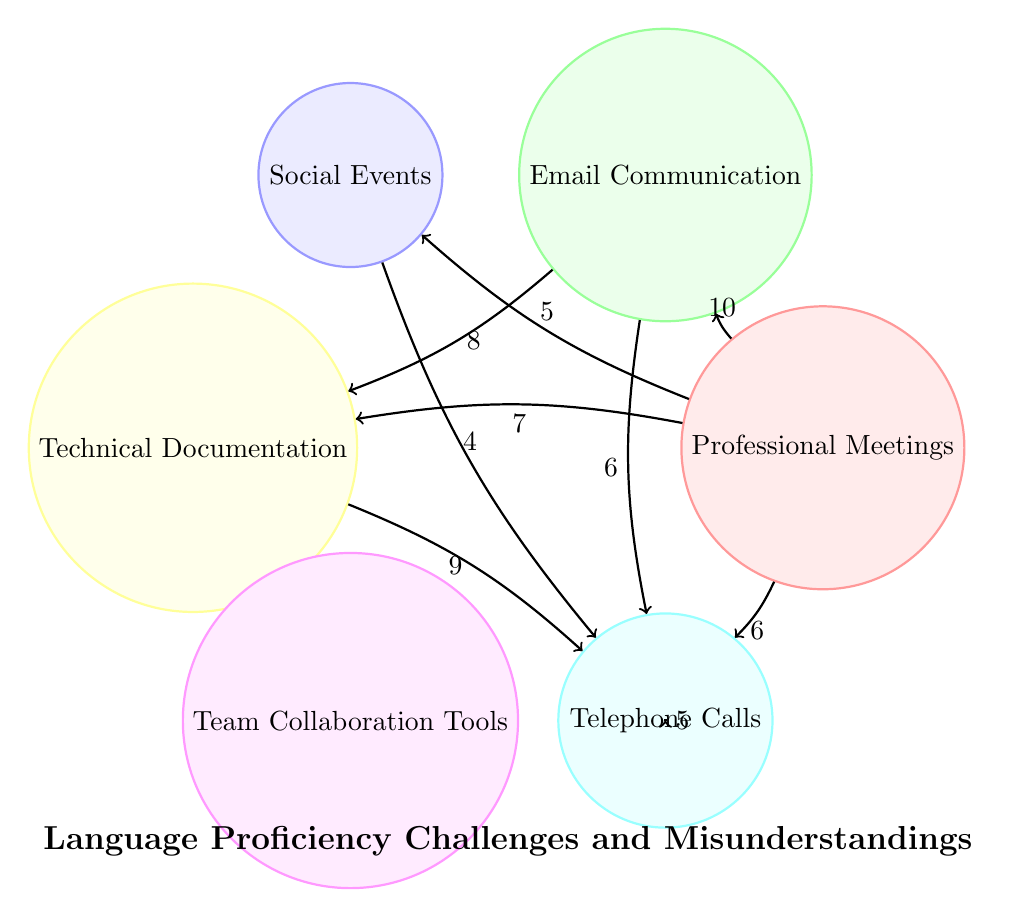What is the value linking Professional Meetings to Email Communication? The diagram shows that the value of the link from Professional Meetings to Email Communication is indicated as 10.
Answer: 10 How many nodes are present in the diagram? The diagram has six nodes: Professional Meetings, Email Communication, Social Events, Technical Documentation, Team Collaboration Tools, and Telephone Calls.
Answer: 6 Which context has the highest frequency of misunderstandings? Looking at the link values, the highest value is 10, which connects Professional Meetings to Email Communication, indicating that it has the highest frequency of misunderstandings.
Answer: Professional Meetings to Email Communication What is the value of misunderstandings between Technical Documentation and Team Collaboration Tools? The link between Technical Documentation and Team Collaboration Tools is presented with a value of 9, indicating the frequency of misunderstandings in that context.
Answer: 9 Which two contexts have the least value based on the linked data? The least values shown in the diagram are 4 between Social Events and Telephone Calls, and 5 between Social Events and Team Collaboration Tools, making these the two contexts with the least link values.
Answer: 4 and 5 If we consider Email Communication, how many total misunderstandings link from it? The links from Email Communication are to Technical Documentation with a value of 8, and to Team Collaboration Tools with a value of 6. Adding those gives a total of 14 misunderstandings linked from Email Communication.
Answer: 14 Which two contexts directly link to Technical Documentation? The contexts that link directly to Technical Documentation are Professional Meetings with a value of 7, and Email Communication with a value of 8.
Answer: Professional Meetings and Email Communication What context has the highest outgoing connection value? Among the nodes, Professional Meetings has outgoing connections to Email Communication (10), Technical Documentation (7), Social Events (5), and Telephone Calls (6). Adding these gives the total of 28, which makes it the highest outgoing connection value.
Answer: Professional Meetings 